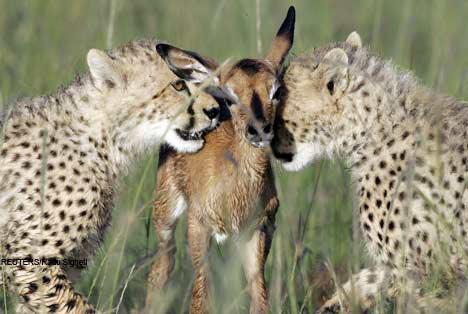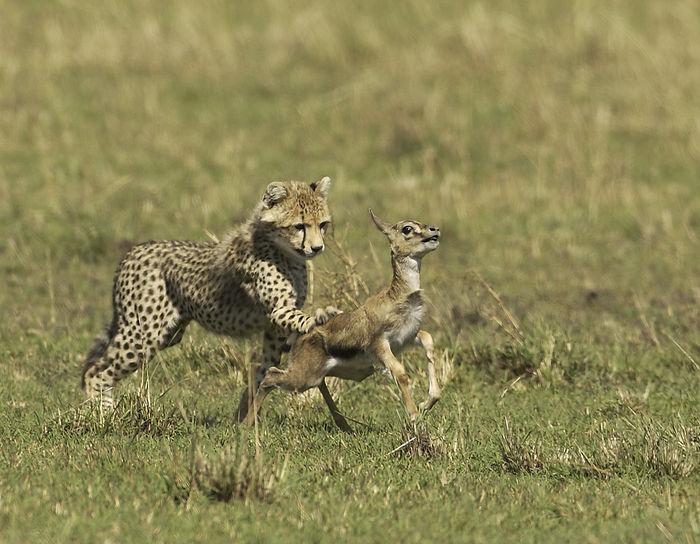The first image is the image on the left, the second image is the image on the right. Assess this claim about the two images: "There are two baby cheetahs hunting a baby gazelle.". Correct or not? Answer yes or no. Yes. 